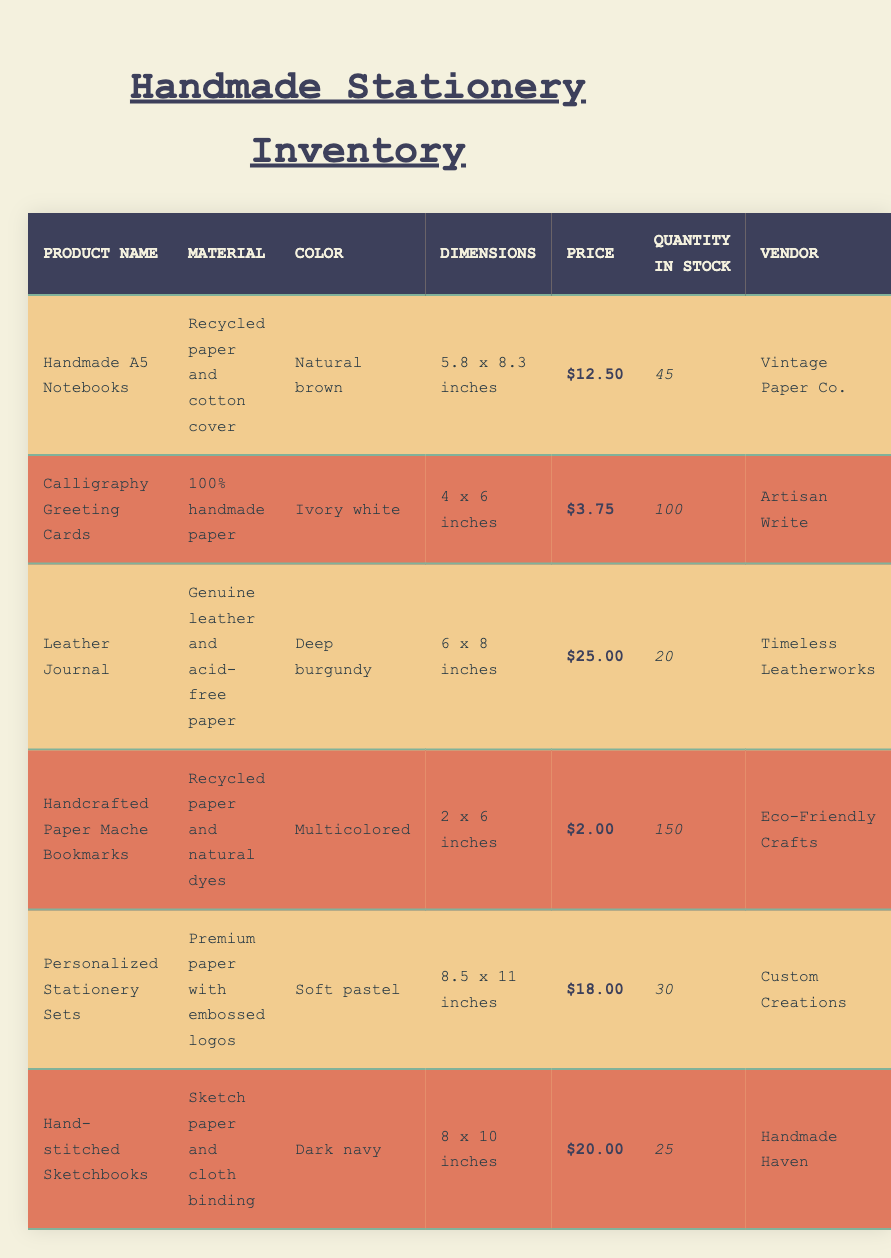What is the price of the Handmade A5 Notebooks? The price information is directly available in the table under the "Price" column for "Handmade A5 Notebooks", which shows $12.50.
Answer: $12.50 How many Calligraphy Greeting Cards are in stock? The quantity in stock for "Calligraphy Greeting Cards" is provided in the "Quantity in Stock" column, which states 100.
Answer: 100 Which product has the highest price? To determine the product with the highest price, we compare the prices of each product: $12.50 (notebooks), $3.75 (cards), $25.00 (journal), $2.00 (bookmarks), $18.00 (stationery sets), and $20.00 (sketchbooks). The highest price is $25.00 for the "Leather Journal."
Answer: Leather Journal How many products have a quantity in stock of less than 30? We can check the "Quantity in Stock" for each product: 45 (notebooks), 100 (cards), 20 (journal), 150 (bookmarks), 30 (stationery sets), and 25 (sketchbooks). The only products with less than 30 are the "Leather Journal" and "Hand-stitched Sketchbooks," totaling 2 products.
Answer: 2 Is the material used in the Handcrafted Paper Mache Bookmarks made from natural dyes? The table states that "Handcrafted Paper Mache Bookmarks" are made from "Recycled paper and natural dyes." Therefore, the answer is yes.
Answer: Yes What is the total number of stationeries available in stock? To find the total number of stationeries, we sum the quantities: 45 (notebooks) + 100 (cards) + 20 (journal) + 150 (bookmarks) + 30 (stationery sets) + 25 (sketchbooks). This equals 370 products in total.
Answer: 370 Which vendor provides the Personalized Stationery Sets? The vendor's name for "Personalized Stationery Sets" is listed in the table under the "Vendor" column, which shows "Custom Creations."
Answer: Custom Creations What is the average price of the items in the inventory? To find the average price, we first sum the prices of the products: $12.50 + $3.75 + $25.00 + $2.00 + $18.00 + $20.00 = $81.25. There are 6 products, so the average price is $81.25 / 6 = approximately $13.54.
Answer: 13.54 How many items are listed under dark navy? The "Color" for "Hand-stitched Sketchbooks" is indicated as "Dark navy." Since this is the only product with that color, the count is 1.
Answer: 1 